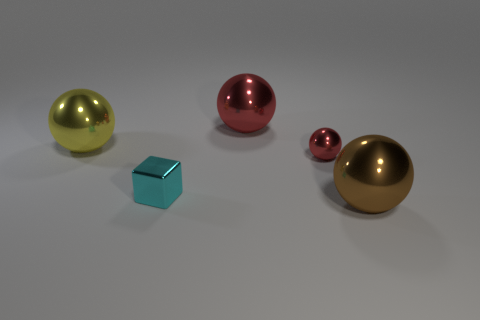Is the big ball that is to the left of the cyan thing made of the same material as the small thing that is behind the cyan shiny object?
Give a very brief answer. Yes. There is a red thing that is in front of the object behind the large yellow object; what size is it?
Provide a short and direct response. Small. Is there anything else that is the same size as the yellow metallic sphere?
Provide a succinct answer. Yes. There is another small object that is the same shape as the brown thing; what material is it?
Keep it short and to the point. Metal. Do the object on the left side of the small metal block and the thing behind the yellow shiny object have the same shape?
Your answer should be very brief. Yes. Are there more big red shiny things than small blue blocks?
Offer a very short reply. Yes. What size is the cyan shiny object?
Ensure brevity in your answer.  Small. How many other objects are there of the same color as the shiny cube?
Offer a very short reply. 0. Is the large ball on the left side of the metallic block made of the same material as the tiny ball?
Make the answer very short. Yes. Is the number of big spheres that are left of the large yellow metal ball less than the number of balls that are on the right side of the small block?
Offer a very short reply. Yes. 